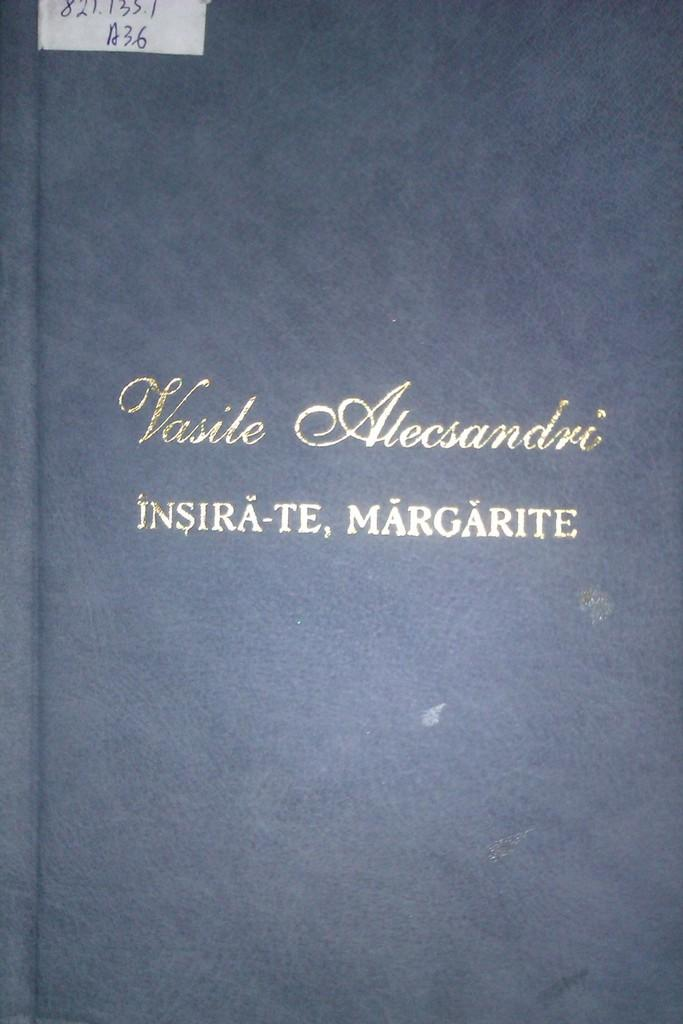Provide a one-sentence caption for the provided image. the word margarite is on the front of the book. 